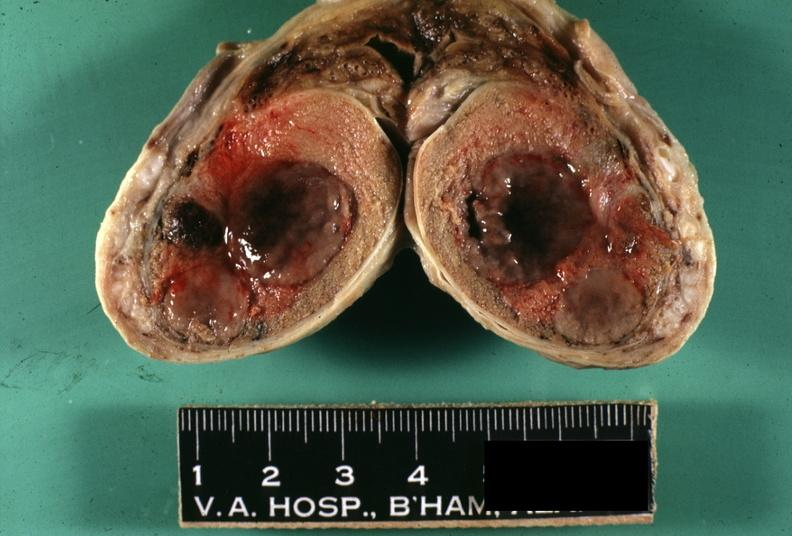s metastatic melanoma present?
Answer the question using a single word or phrase. Yes 